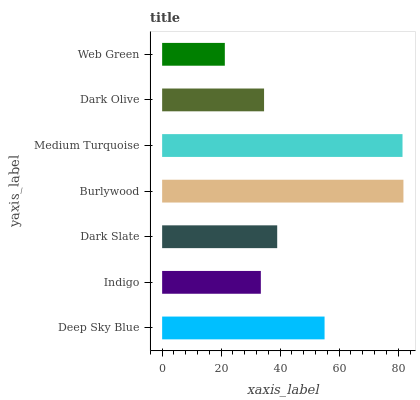Is Web Green the minimum?
Answer yes or no. Yes. Is Burlywood the maximum?
Answer yes or no. Yes. Is Indigo the minimum?
Answer yes or no. No. Is Indigo the maximum?
Answer yes or no. No. Is Deep Sky Blue greater than Indigo?
Answer yes or no. Yes. Is Indigo less than Deep Sky Blue?
Answer yes or no. Yes. Is Indigo greater than Deep Sky Blue?
Answer yes or no. No. Is Deep Sky Blue less than Indigo?
Answer yes or no. No. Is Dark Slate the high median?
Answer yes or no. Yes. Is Dark Slate the low median?
Answer yes or no. Yes. Is Web Green the high median?
Answer yes or no. No. Is Indigo the low median?
Answer yes or no. No. 